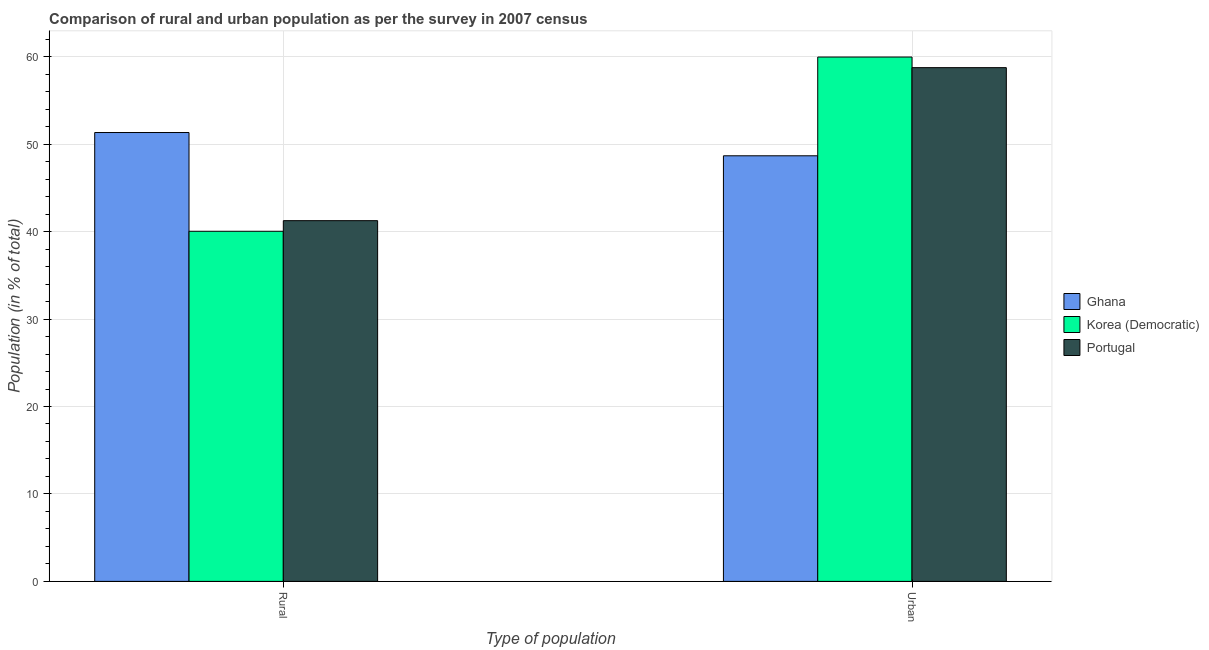How many groups of bars are there?
Offer a very short reply. 2. Are the number of bars on each tick of the X-axis equal?
Keep it short and to the point. Yes. How many bars are there on the 1st tick from the right?
Give a very brief answer. 3. What is the label of the 1st group of bars from the left?
Offer a very short reply. Rural. What is the rural population in Ghana?
Make the answer very short. 51.33. Across all countries, what is the maximum urban population?
Make the answer very short. 59.96. Across all countries, what is the minimum rural population?
Your answer should be very brief. 40.04. In which country was the urban population maximum?
Ensure brevity in your answer.  Korea (Democratic). In which country was the urban population minimum?
Make the answer very short. Ghana. What is the total urban population in the graph?
Offer a terse response. 167.38. What is the difference between the rural population in Korea (Democratic) and that in Portugal?
Make the answer very short. -1.21. What is the difference between the rural population in Ghana and the urban population in Korea (Democratic)?
Provide a short and direct response. -8.63. What is the average urban population per country?
Offer a very short reply. 55.79. What is the difference between the rural population and urban population in Portugal?
Offer a terse response. -17.5. What is the ratio of the rural population in Ghana to that in Korea (Democratic)?
Offer a terse response. 1.28. In how many countries, is the rural population greater than the average rural population taken over all countries?
Provide a short and direct response. 1. What does the 2nd bar from the left in Rural represents?
Ensure brevity in your answer.  Korea (Democratic). How many countries are there in the graph?
Offer a very short reply. 3. Are the values on the major ticks of Y-axis written in scientific E-notation?
Provide a short and direct response. No. Does the graph contain any zero values?
Keep it short and to the point. No. How many legend labels are there?
Provide a short and direct response. 3. How are the legend labels stacked?
Provide a succinct answer. Vertical. What is the title of the graph?
Provide a succinct answer. Comparison of rural and urban population as per the survey in 2007 census. Does "Albania" appear as one of the legend labels in the graph?
Your response must be concise. No. What is the label or title of the X-axis?
Offer a very short reply. Type of population. What is the label or title of the Y-axis?
Your response must be concise. Population (in % of total). What is the Population (in % of total) in Ghana in Rural?
Ensure brevity in your answer.  51.33. What is the Population (in % of total) of Korea (Democratic) in Rural?
Provide a short and direct response. 40.04. What is the Population (in % of total) in Portugal in Rural?
Offer a terse response. 41.25. What is the Population (in % of total) of Ghana in Urban?
Provide a short and direct response. 48.67. What is the Population (in % of total) in Korea (Democratic) in Urban?
Your response must be concise. 59.96. What is the Population (in % of total) of Portugal in Urban?
Offer a terse response. 58.75. Across all Type of population, what is the maximum Population (in % of total) of Ghana?
Ensure brevity in your answer.  51.33. Across all Type of population, what is the maximum Population (in % of total) of Korea (Democratic)?
Ensure brevity in your answer.  59.96. Across all Type of population, what is the maximum Population (in % of total) of Portugal?
Make the answer very short. 58.75. Across all Type of population, what is the minimum Population (in % of total) of Ghana?
Provide a short and direct response. 48.67. Across all Type of population, what is the minimum Population (in % of total) of Korea (Democratic)?
Keep it short and to the point. 40.04. Across all Type of population, what is the minimum Population (in % of total) in Portugal?
Offer a terse response. 41.25. What is the total Population (in % of total) of Ghana in the graph?
Your response must be concise. 100. What is the total Population (in % of total) in Korea (Democratic) in the graph?
Your response must be concise. 100. What is the total Population (in % of total) of Portugal in the graph?
Make the answer very short. 100. What is the difference between the Population (in % of total) in Ghana in Rural and that in Urban?
Make the answer very short. 2.66. What is the difference between the Population (in % of total) of Korea (Democratic) in Rural and that in Urban?
Your answer should be very brief. -19.92. What is the difference between the Population (in % of total) of Portugal in Rural and that in Urban?
Offer a terse response. -17.5. What is the difference between the Population (in % of total) of Ghana in Rural and the Population (in % of total) of Korea (Democratic) in Urban?
Your answer should be compact. -8.63. What is the difference between the Population (in % of total) in Ghana in Rural and the Population (in % of total) in Portugal in Urban?
Keep it short and to the point. -7.42. What is the difference between the Population (in % of total) in Korea (Democratic) in Rural and the Population (in % of total) in Portugal in Urban?
Ensure brevity in your answer.  -18.71. What is the average Population (in % of total) in Ghana per Type of population?
Make the answer very short. 50. What is the average Population (in % of total) of Portugal per Type of population?
Provide a short and direct response. 50. What is the difference between the Population (in % of total) of Ghana and Population (in % of total) of Korea (Democratic) in Rural?
Keep it short and to the point. 11.29. What is the difference between the Population (in % of total) of Ghana and Population (in % of total) of Portugal in Rural?
Keep it short and to the point. 10.08. What is the difference between the Population (in % of total) in Korea (Democratic) and Population (in % of total) in Portugal in Rural?
Your answer should be very brief. -1.21. What is the difference between the Population (in % of total) of Ghana and Population (in % of total) of Korea (Democratic) in Urban?
Give a very brief answer. -11.29. What is the difference between the Population (in % of total) in Ghana and Population (in % of total) in Portugal in Urban?
Offer a terse response. -10.08. What is the difference between the Population (in % of total) in Korea (Democratic) and Population (in % of total) in Portugal in Urban?
Your answer should be very brief. 1.21. What is the ratio of the Population (in % of total) of Ghana in Rural to that in Urban?
Give a very brief answer. 1.05. What is the ratio of the Population (in % of total) of Korea (Democratic) in Rural to that in Urban?
Provide a short and direct response. 0.67. What is the ratio of the Population (in % of total) in Portugal in Rural to that in Urban?
Provide a short and direct response. 0.7. What is the difference between the highest and the second highest Population (in % of total) in Ghana?
Keep it short and to the point. 2.66. What is the difference between the highest and the second highest Population (in % of total) in Korea (Democratic)?
Offer a terse response. 19.92. What is the difference between the highest and the second highest Population (in % of total) in Portugal?
Give a very brief answer. 17.5. What is the difference between the highest and the lowest Population (in % of total) in Ghana?
Keep it short and to the point. 2.66. What is the difference between the highest and the lowest Population (in % of total) in Korea (Democratic)?
Keep it short and to the point. 19.92. What is the difference between the highest and the lowest Population (in % of total) in Portugal?
Your response must be concise. 17.5. 